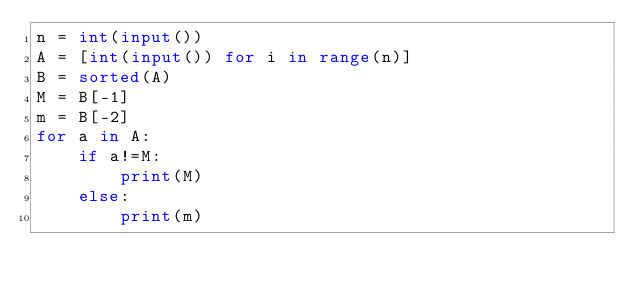<code> <loc_0><loc_0><loc_500><loc_500><_Python_>n = int(input())
A = [int(input()) for i in range(n)]
B = sorted(A)
M = B[-1]
m = B[-2]
for a in A:
    if a!=M:
        print(M)
    else:
        print(m)</code> 